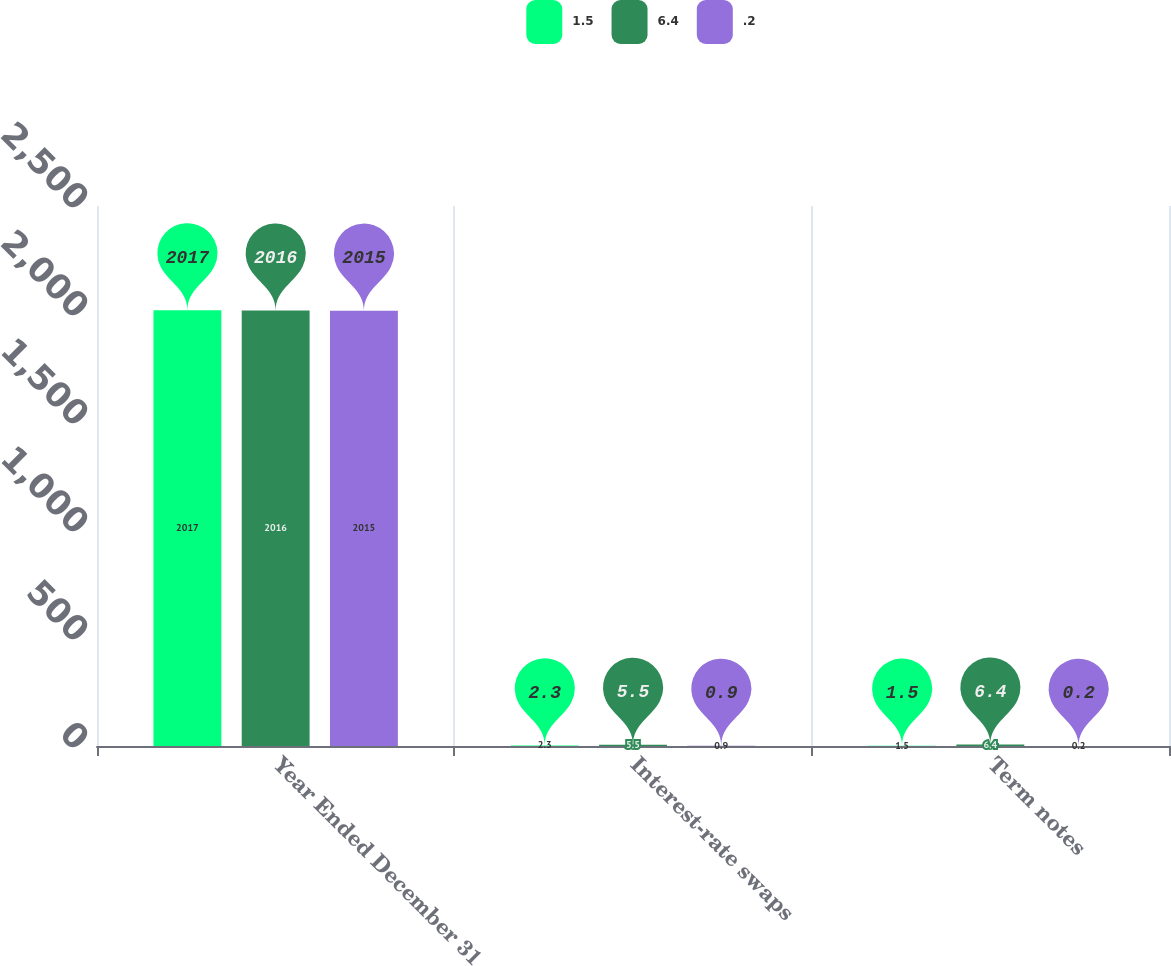Convert chart. <chart><loc_0><loc_0><loc_500><loc_500><stacked_bar_chart><ecel><fcel>Year Ended December 31<fcel>Interest-rate swaps<fcel>Term notes<nl><fcel>1.5<fcel>2017<fcel>2.3<fcel>1.5<nl><fcel>6.4<fcel>2016<fcel>5.5<fcel>6.4<nl><fcel>0.2<fcel>2015<fcel>0.9<fcel>0.2<nl></chart> 